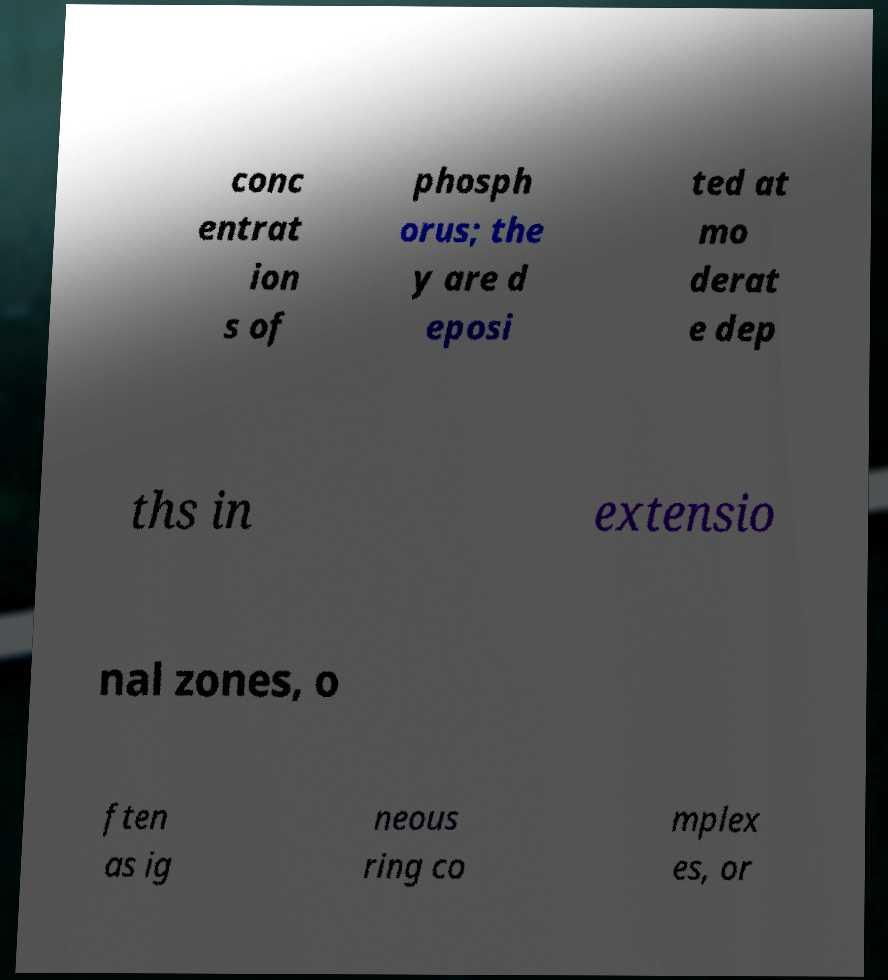I need the written content from this picture converted into text. Can you do that? conc entrat ion s of phosph orus; the y are d eposi ted at mo derat e dep ths in extensio nal zones, o ften as ig neous ring co mplex es, or 